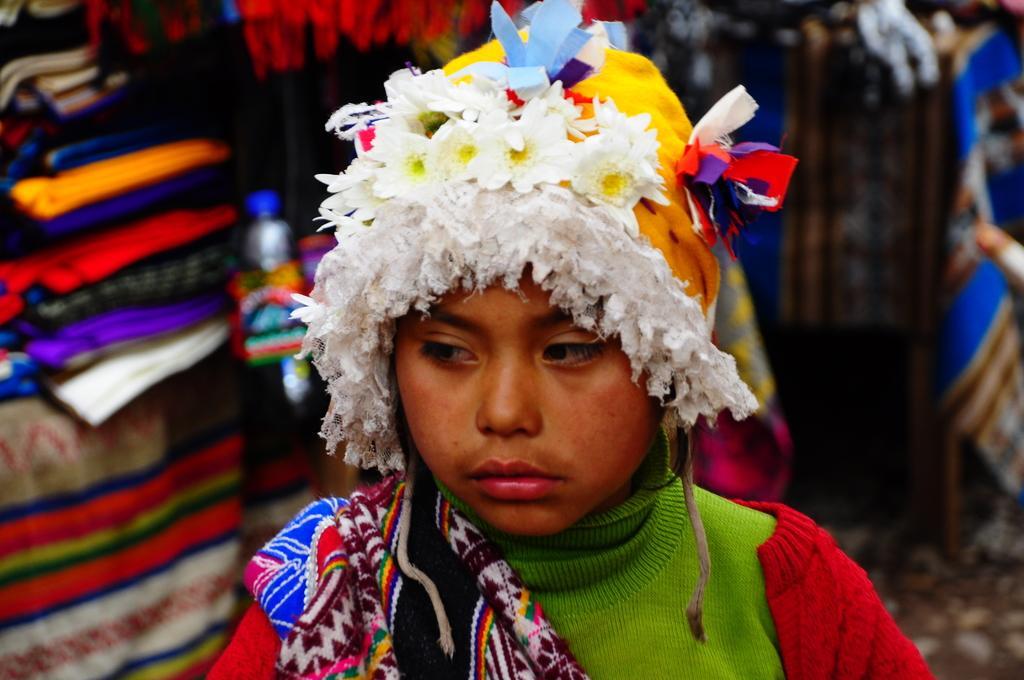In one or two sentences, can you explain what this image depicts? In this image, we can see a person is wearing colorful cap and woolen clothes. Here we can see colorful cloth on a person's shoulder. Background we can see a blur view. Here we can see few objects, things and bottle. 